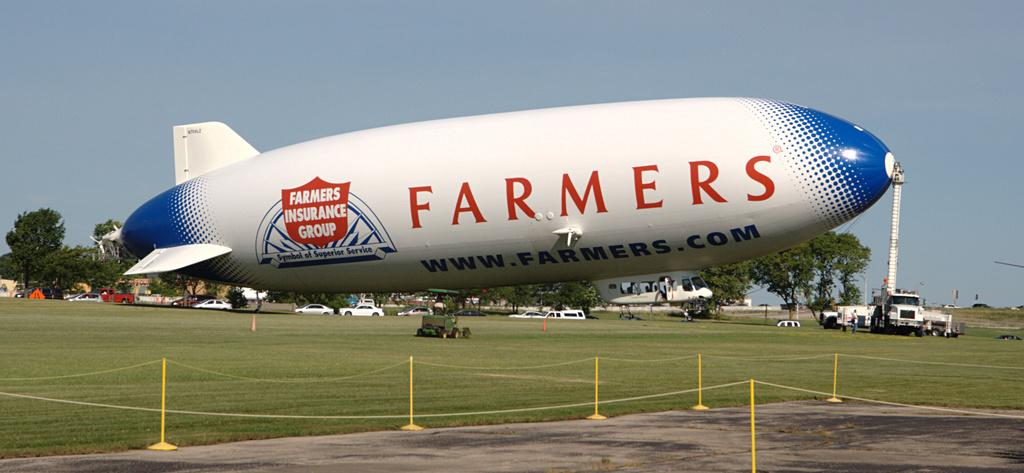What type of vehicle is present in the image? There are vehicles in the image, but the specific type cannot be determined from the provided facts. What is the color of the stand in the image? The stand in the image is small and yellow. How is the stand connected to the ground in the image? A rope is attached to the stand and visible on the ground in the image. What is visible at the top of the image? The sky is visible at the top of the image. What type of breakfast is being served on the ship in the image? There is no mention of breakfast or any food being served in the image. How does the journey of the ship in the image progress? The image does not show the ship in motion or provide any information about its journey. 